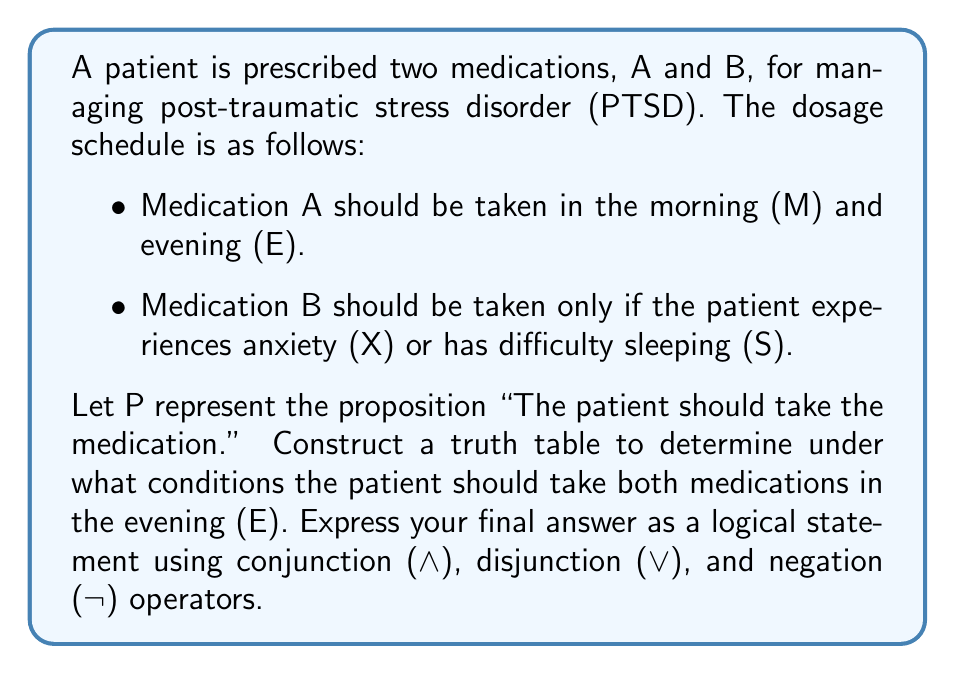Help me with this question. To solve this problem, we need to construct a truth table and analyze the logical structure of the medication schedule. Let's break it down step by step:

1. Identify the relevant propositions:
   - A: The patient should take Medication A
   - B: The patient should take Medication B
   - X: The patient experiences anxiety
   - S: The patient has difficulty sleeping
   - E: It is evening time

2. Construct the truth table:
   We need to consider all possible combinations of X, S, and E, and determine when A and B should be taken.

   $$ \begin{array}{|c|c|c|c|c|}
   \hline
   X & S & E & A & B & P \\
   \hline
   T & T & T & T & T & T \\
   T & T & F & T & T & F \\
   T & F & T & T & T & T \\
   T & F & F & T & T & F \\
   F & T & T & T & T & T \\
   F & T & F & T & T & F \\
   F & F & T & T & F & F \\
   F & F & F & T & F & F \\
   \hline
   \end{array} $$

3. Analyze the truth table:
   - A is always T because it should be taken in the morning and evening.
   - B is T when either X or S is T (X ∨ S).
   - P (taking both medications in the evening) is T when E is T and B is T.

4. Formulate the logical statement:
   The patient should take both medications in the evening when it is evening time (E) AND either anxiety is present (X) OR there is difficulty sleeping (S).

   This can be expressed as: $P = E ∧ (X ∨ S)$
Answer: $P = E ∧ (X ∨ S)$ 